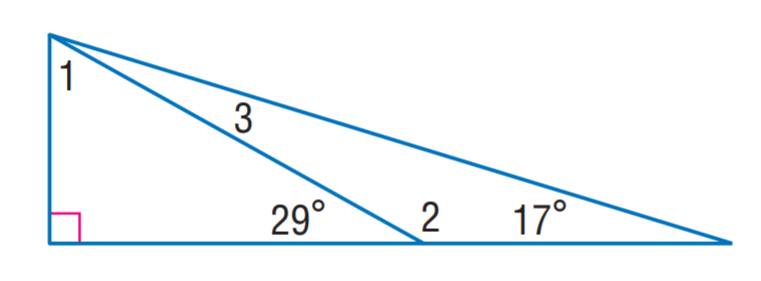Answer the mathemtical geometry problem and directly provide the correct option letter.
Question: Find m \angle 3.
Choices: A: 12 B: 17 C: 61 D: 151 A 